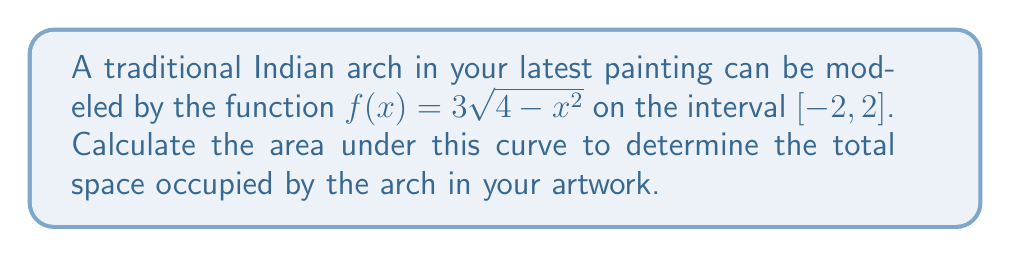Teach me how to tackle this problem. To find the area under the curve, we need to integrate the function over the given interval. Let's approach this step-by-step:

1) The area under the curve is given by the definite integral:

   $$A = \int_{-2}^{2} f(x) dx = \int_{-2}^{2} 3\sqrt{4-x^2} dx$$

2) This integral can be solved using trigonometric substitution. Let $x = 2\sin\theta$. Then:
   
   $dx = 2\cos\theta d\theta$
   $\sqrt{4-x^2} = \sqrt{4-4\sin^2\theta} = 2\cos\theta$

3) When $x = -2$, $\theta = -\frac{\pi}{2}$, and when $x = 2$, $\theta = \frac{\pi}{2}$

4) Substituting these into our integral:

   $$A = \int_{-\frac{\pi}{2}}^{\frac{\pi}{2}} 3(2\cos\theta)(2\cos\theta) d\theta = 12\int_{-\frac{\pi}{2}}^{\frac{\pi}{2}} \cos^2\theta d\theta$$

5) We can use the identity $\cos^2\theta = \frac{1+\cos(2\theta)}{2}$:

   $$A = 12\int_{-\frac{\pi}{2}}^{\frac{\pi}{2}} \frac{1+\cos(2\theta)}{2} d\theta = 6\int_{-\frac{\pi}{2}}^{\frac{\pi}{2}} (1+\cos(2\theta)) d\theta$$

6) Integrating:

   $$A = 6[\theta + \frac{1}{2}\sin(2\theta)]_{-\frac{\pi}{2}}^{\frac{\pi}{2}}$$

7) Evaluating the limits:

   $$A = 6[(\frac{\pi}{2} + 0) - (-\frac{\pi}{2} + 0)] = 6\pi$$

Therefore, the area under the curve representing the arc of the traditional Indian arch in your painting is $6\pi$ square units.
Answer: $6\pi$ square units 